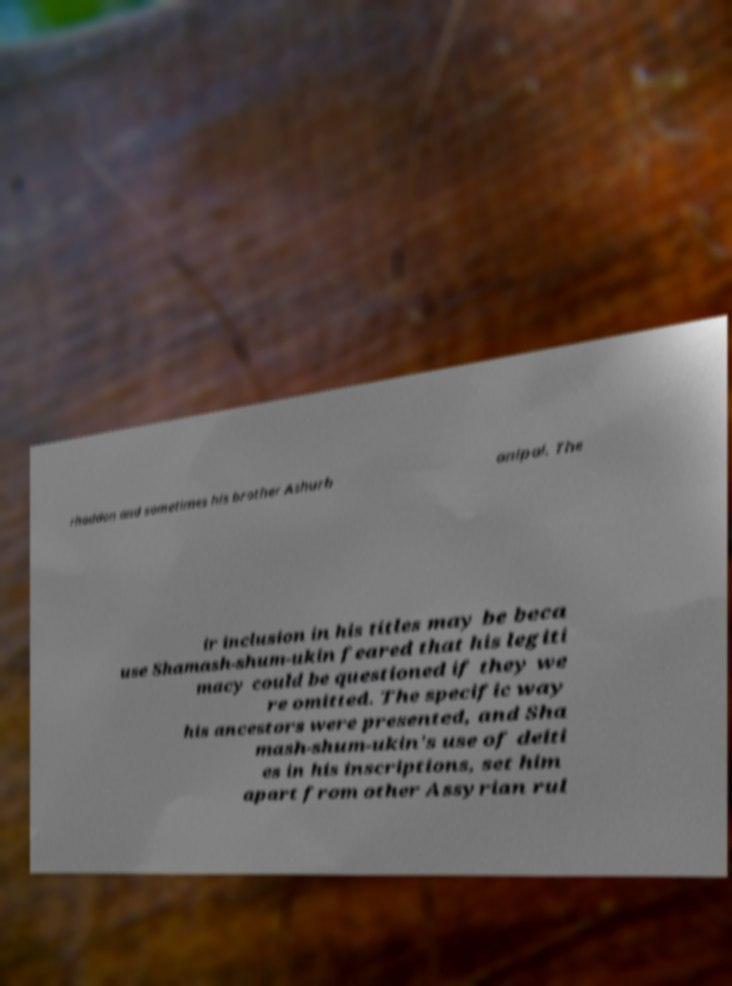Can you read and provide the text displayed in the image?This photo seems to have some interesting text. Can you extract and type it out for me? rhaddon and sometimes his brother Ashurb anipal. The ir inclusion in his titles may be beca use Shamash-shum-ukin feared that his legiti macy could be questioned if they we re omitted. The specific way his ancestors were presented, and Sha mash-shum-ukin's use of deiti es in his inscriptions, set him apart from other Assyrian rul 